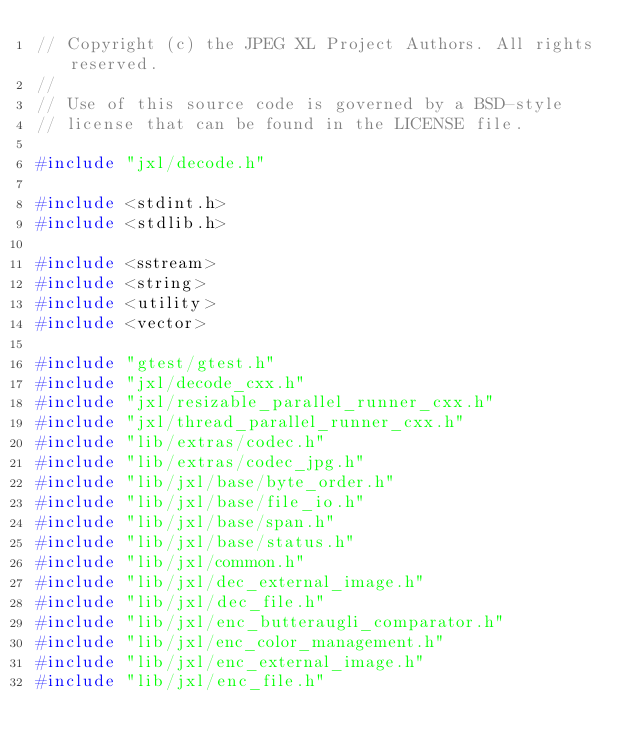Convert code to text. <code><loc_0><loc_0><loc_500><loc_500><_C++_>// Copyright (c) the JPEG XL Project Authors. All rights reserved.
//
// Use of this source code is governed by a BSD-style
// license that can be found in the LICENSE file.

#include "jxl/decode.h"

#include <stdint.h>
#include <stdlib.h>

#include <sstream>
#include <string>
#include <utility>
#include <vector>

#include "gtest/gtest.h"
#include "jxl/decode_cxx.h"
#include "jxl/resizable_parallel_runner_cxx.h"
#include "jxl/thread_parallel_runner_cxx.h"
#include "lib/extras/codec.h"
#include "lib/extras/codec_jpg.h"
#include "lib/jxl/base/byte_order.h"
#include "lib/jxl/base/file_io.h"
#include "lib/jxl/base/span.h"
#include "lib/jxl/base/status.h"
#include "lib/jxl/common.h"
#include "lib/jxl/dec_external_image.h"
#include "lib/jxl/dec_file.h"
#include "lib/jxl/enc_butteraugli_comparator.h"
#include "lib/jxl/enc_color_management.h"
#include "lib/jxl/enc_external_image.h"
#include "lib/jxl/enc_file.h"</code> 